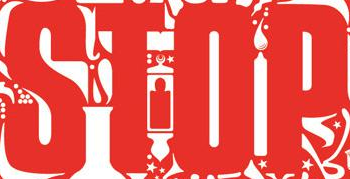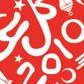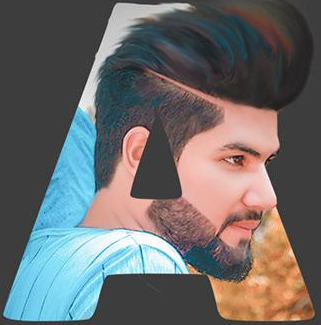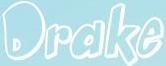What words are shown in these images in order, separated by a semicolon? STOP; 2010; A; Drake 